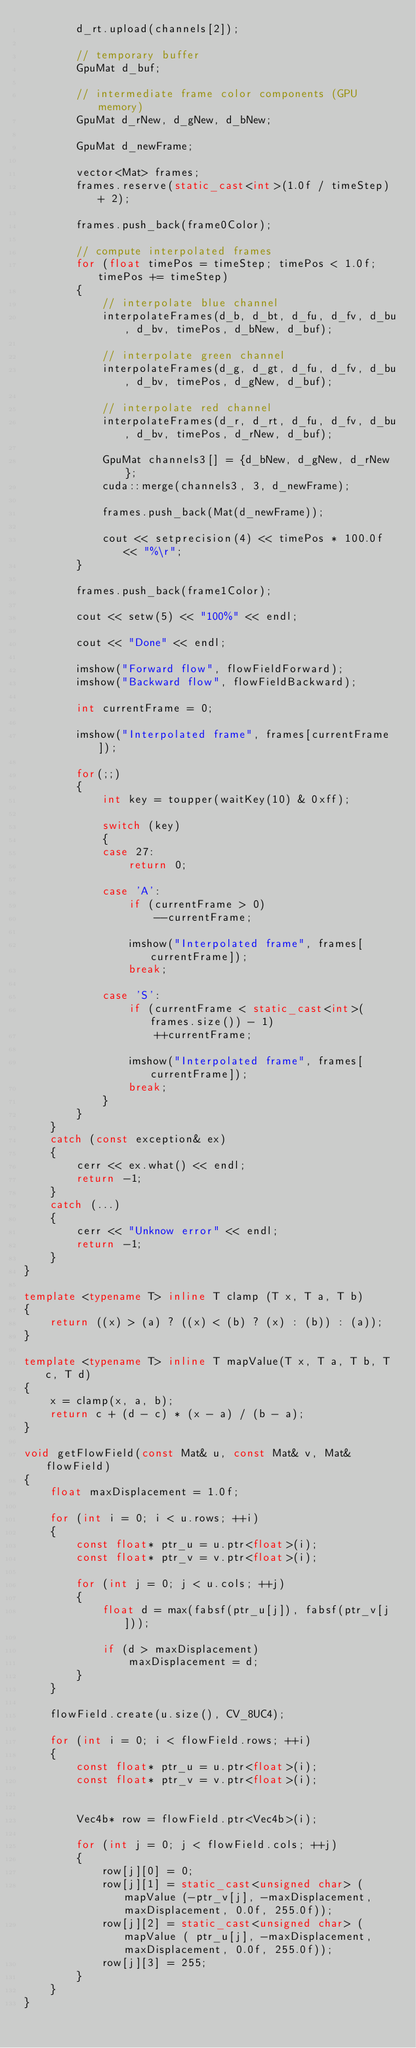<code> <loc_0><loc_0><loc_500><loc_500><_C++_>        d_rt.upload(channels[2]);

        // temporary buffer
        GpuMat d_buf;

        // intermediate frame color components (GPU memory)
        GpuMat d_rNew, d_gNew, d_bNew;

        GpuMat d_newFrame;

        vector<Mat> frames;
        frames.reserve(static_cast<int>(1.0f / timeStep) + 2);

        frames.push_back(frame0Color);

        // compute interpolated frames
        for (float timePos = timeStep; timePos < 1.0f; timePos += timeStep)
        {
            // interpolate blue channel
            interpolateFrames(d_b, d_bt, d_fu, d_fv, d_bu, d_bv, timePos, d_bNew, d_buf);

            // interpolate green channel
            interpolateFrames(d_g, d_gt, d_fu, d_fv, d_bu, d_bv, timePos, d_gNew, d_buf);

            // interpolate red channel
            interpolateFrames(d_r, d_rt, d_fu, d_fv, d_bu, d_bv, timePos, d_rNew, d_buf);

            GpuMat channels3[] = {d_bNew, d_gNew, d_rNew};
            cuda::merge(channels3, 3, d_newFrame);

            frames.push_back(Mat(d_newFrame));

            cout << setprecision(4) << timePos * 100.0f << "%\r";
        }

        frames.push_back(frame1Color);

        cout << setw(5) << "100%" << endl;

        cout << "Done" << endl;

        imshow("Forward flow", flowFieldForward);
        imshow("Backward flow", flowFieldBackward);

        int currentFrame = 0;

        imshow("Interpolated frame", frames[currentFrame]);

        for(;;)
        {
            int key = toupper(waitKey(10) & 0xff);

            switch (key)
            {
            case 27:
                return 0;

            case 'A':
                if (currentFrame > 0)
                    --currentFrame;

                imshow("Interpolated frame", frames[currentFrame]);
                break;

            case 'S':
                if (currentFrame < static_cast<int>(frames.size()) - 1)
                    ++currentFrame;

                imshow("Interpolated frame", frames[currentFrame]);
                break;
            }
        }
    }
    catch (const exception& ex)
    {
        cerr << ex.what() << endl;
        return -1;
    }
    catch (...)
    {
        cerr << "Unknow error" << endl;
        return -1;
    }
}

template <typename T> inline T clamp (T x, T a, T b)
{
    return ((x) > (a) ? ((x) < (b) ? (x) : (b)) : (a));
}

template <typename T> inline T mapValue(T x, T a, T b, T c, T d)
{
    x = clamp(x, a, b);
    return c + (d - c) * (x - a) / (b - a);
}

void getFlowField(const Mat& u, const Mat& v, Mat& flowField)
{
    float maxDisplacement = 1.0f;

    for (int i = 0; i < u.rows; ++i)
    {
        const float* ptr_u = u.ptr<float>(i);
        const float* ptr_v = v.ptr<float>(i);

        for (int j = 0; j < u.cols; ++j)
        {
            float d = max(fabsf(ptr_u[j]), fabsf(ptr_v[j]));

            if (d > maxDisplacement)
                maxDisplacement = d;
        }
    }

    flowField.create(u.size(), CV_8UC4);

    for (int i = 0; i < flowField.rows; ++i)
    {
        const float* ptr_u = u.ptr<float>(i);
        const float* ptr_v = v.ptr<float>(i);


        Vec4b* row = flowField.ptr<Vec4b>(i);

        for (int j = 0; j < flowField.cols; ++j)
        {
            row[j][0] = 0;
            row[j][1] = static_cast<unsigned char> (mapValue (-ptr_v[j], -maxDisplacement, maxDisplacement, 0.0f, 255.0f));
            row[j][2] = static_cast<unsigned char> (mapValue ( ptr_u[j], -maxDisplacement, maxDisplacement, 0.0f, 255.0f));
            row[j][3] = 255;
        }
    }
}
</code> 